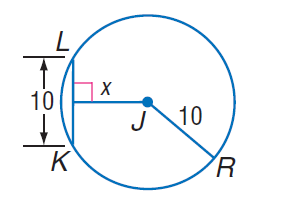Answer the mathemtical geometry problem and directly provide the correct option letter.
Question: Find x.
Choices: A: 5 B: 5 \sqrt { 3 } C: 10 D: 15 B 